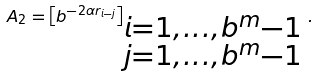Convert formula to latex. <formula><loc_0><loc_0><loc_500><loc_500>A _ { 2 } = \left [ b ^ { - 2 \alpha r _ { i - j } } \right ] _ { \begin{subarray} { c } i = 1 , \dots , b ^ { m } - 1 \\ j = 1 , \dots , b ^ { m } - 1 \end{subarray} } \, .</formula> 